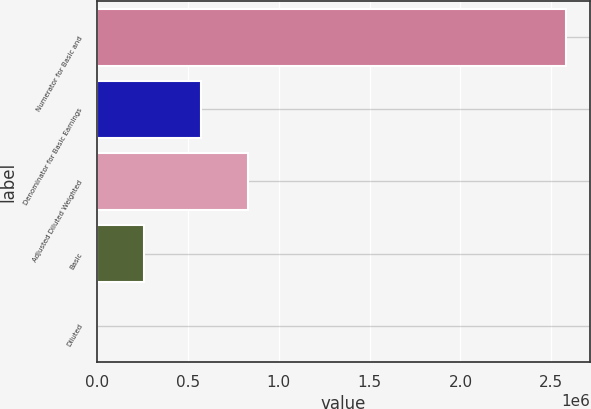<chart> <loc_0><loc_0><loc_500><loc_500><bar_chart><fcel>Numerator for Basic and<fcel>Denominator for Basic Earnings<fcel>Adjusted Diluted Weighted<fcel>Basic<fcel>Diluted<nl><fcel>2.58258e+06<fcel>574620<fcel>832877<fcel>258262<fcel>4.46<nl></chart> 